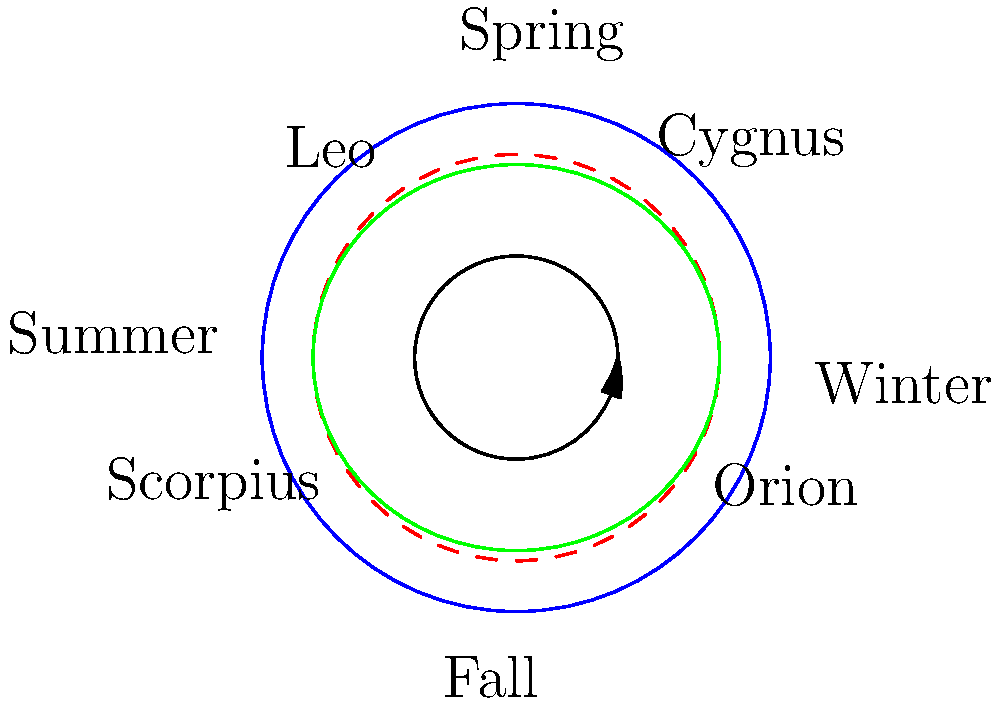As a trusted counselor, you're often asked about various topics. Tonight, a friend seeks your wisdom about the night sky. They wonder why certain constellations are visible during specific seasons and not others. Using the diagram, explain the seasonal changes in constellation visibility and identify which constellation would be most prominent in a summer evening sky. To understand the seasonal changes in constellation visibility, let's break it down step-by-step:

1. Earth's rotation and orbit:
   - The Earth rotates on its axis, causing the daily rise and set of stars.
   - It also orbits around the Sun, which takes approximately 365.25 days.

2. Celestial sphere:
   - The blue circle in the diagram represents the celestial sphere, an imaginary sphere surrounding Earth.
   - Stars and constellations appear fixed on this sphere.

3. Celestial equator and ecliptic:
   - The red dashed line represents the celestial equator, an extension of Earth's equator.
   - The green ellipse represents the ecliptic, which is the Sun's apparent path through the sky.

4. Seasonal changes:
   - As Earth orbits the Sun, our night sky view gradually shifts.
   - Different parts of the celestial sphere become visible at night in different seasons.

5. Constellations and seasons:
   - The diagram shows four constellations: Orion, Leo, Scorpius, and Cygnus.
   - Their positions correspond to the seasons when they're most visible at night.

6. Summer evening sky:
   - In summer, Earth's night side faces the part of the sky opposite the Sun's winter position.
   - Looking at the diagram, we see Scorpius is positioned near the "Summer" label.

Therefore, among the constellations shown, Scorpius would be the most prominent in a summer evening sky.
Answer: Scorpius 